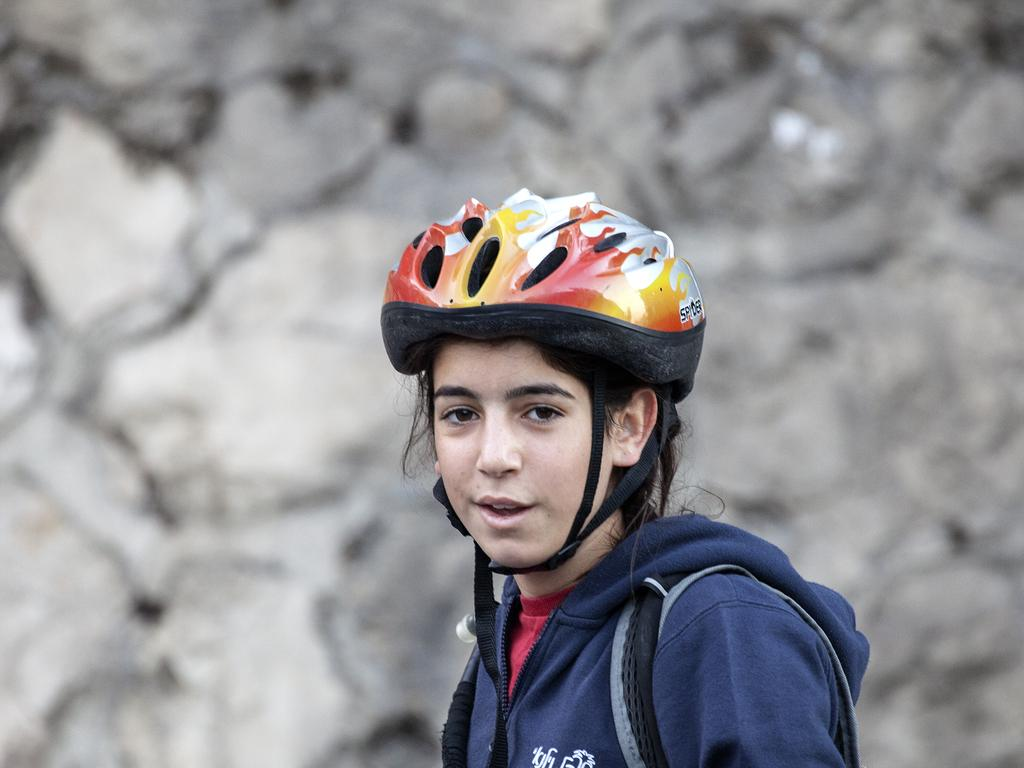What is the main subject of the picture? There is a person in the picture. What is the person wearing on their head? The person is wearing a helmet. What type of clothing is the person wearing on their upper body? The person is wearing a sweater. Can you describe the background of the image? The background of the image is blurry. What type of gold jewelry is the girl wearing in the image? There is no girl or gold jewelry present in the image; it features a person wearing a helmet and a sweater. What type of support can be seen in the image? There is no support visible in the image; it only features a person wearing a helmet and a sweater against a blurry background. 